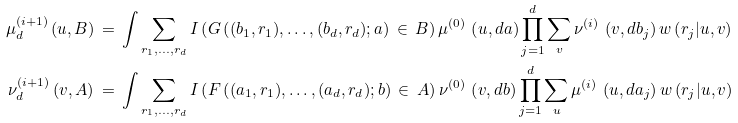Convert formula to latex. <formula><loc_0><loc_0><loc_500><loc_500>\mu _ { d } ^ { ( i + 1 ) } \, ( u , B ) & \, = \, \int \sum _ { r _ { 1 } , \dots , r _ { d } } I \left ( G \left ( ( b _ { 1 } , r _ { 1 } ) , \dots , ( b _ { d } , r _ { d } ) ; a \right ) \, \in \, B \right ) \mu ^ { ( 0 ) } \, \left ( u , d a \right ) \prod _ { j = 1 } ^ { d } \sum _ { v } \nu ^ { ( i ) } \, \left ( v , d b _ { j } \right ) w \left ( r _ { j } | u , v \right ) \\ \nu _ { d } ^ { ( i + 1 ) } \, ( v , A ) & \, = \, \int \sum _ { r _ { 1 } , \dots , r _ { d } } I \left ( F \left ( ( a _ { 1 } , r _ { 1 } ) , \dots , ( a _ { d } , r _ { d } ) ; b \right ) \, \in \, A \right ) \nu ^ { ( 0 ) } \, \left ( v , d b \right ) \prod _ { j = 1 } ^ { d } \sum _ { u } \mu ^ { ( i ) } \, \left ( u , d a _ { j } \right ) w \left ( r _ { j } | u , v \right )</formula> 